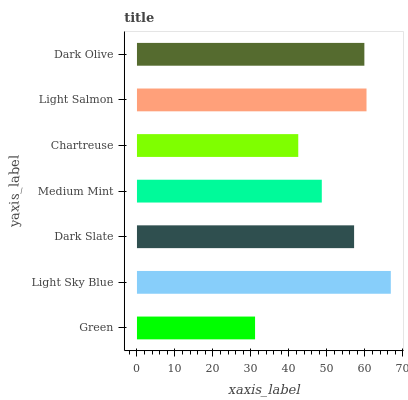Is Green the minimum?
Answer yes or no. Yes. Is Light Sky Blue the maximum?
Answer yes or no. Yes. Is Dark Slate the minimum?
Answer yes or no. No. Is Dark Slate the maximum?
Answer yes or no. No. Is Light Sky Blue greater than Dark Slate?
Answer yes or no. Yes. Is Dark Slate less than Light Sky Blue?
Answer yes or no. Yes. Is Dark Slate greater than Light Sky Blue?
Answer yes or no. No. Is Light Sky Blue less than Dark Slate?
Answer yes or no. No. Is Dark Slate the high median?
Answer yes or no. Yes. Is Dark Slate the low median?
Answer yes or no. Yes. Is Dark Olive the high median?
Answer yes or no. No. Is Light Sky Blue the low median?
Answer yes or no. No. 